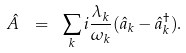Convert formula to latex. <formula><loc_0><loc_0><loc_500><loc_500>\hat { A } \ = \ \sum _ { k } i \frac { \lambda _ { k } } { \omega _ { k } } ( \hat { a } _ { k } - \hat { a } _ { k } ^ { \dagger } ) .</formula> 